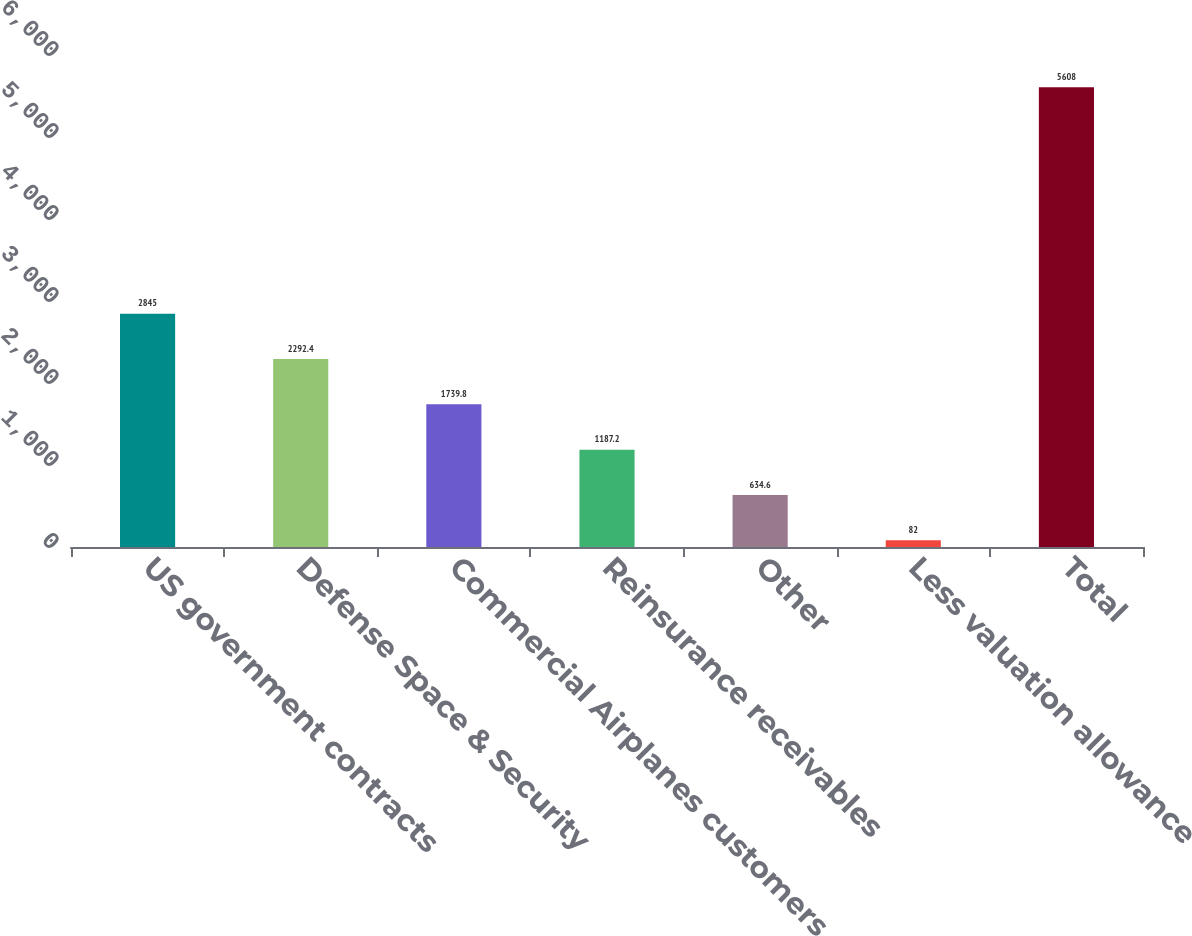Convert chart to OTSL. <chart><loc_0><loc_0><loc_500><loc_500><bar_chart><fcel>US government contracts<fcel>Defense Space & Security<fcel>Commercial Airplanes customers<fcel>Reinsurance receivables<fcel>Other<fcel>Less valuation allowance<fcel>Total<nl><fcel>2845<fcel>2292.4<fcel>1739.8<fcel>1187.2<fcel>634.6<fcel>82<fcel>5608<nl></chart> 